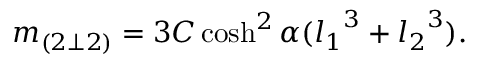Convert formula to latex. <formula><loc_0><loc_0><loc_500><loc_500>m _ { ( 2 \bot 2 ) } = 3 C \cosh ^ { 2 } \alpha ( { l _ { 1 } } ^ { 3 } + { l _ { 2 } } ^ { 3 } ) .</formula> 